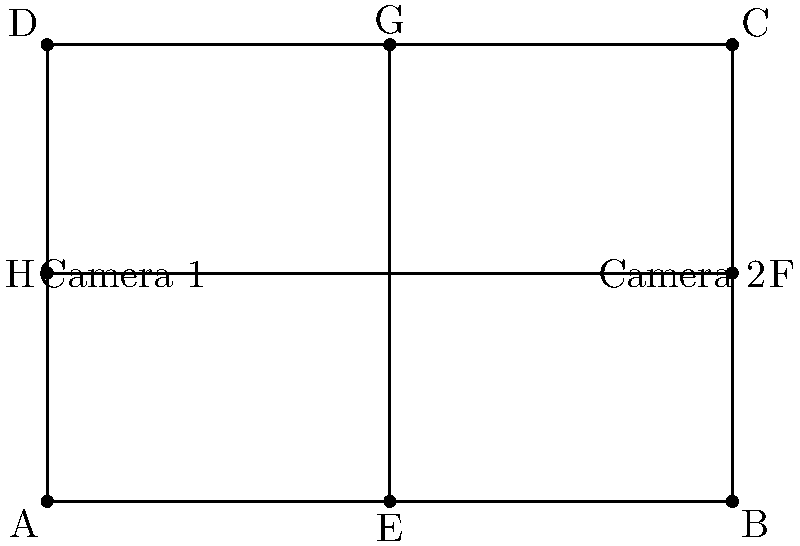A rectangular property has security cameras installed at points E and F as shown in the diagram. If these cameras are reflected across the diagonal AC to create a symmetrical layout, where will the new camera positions be located? To solve this problem, we need to understand the concept of reflection symmetry across a diagonal. Here's a step-by-step explanation:

1. Identify the line of symmetry: In this case, it's the diagonal AC of the rectangular property.

2. For Camera 1 at point E:
   a. Draw a perpendicular line from E to AC.
   b. Extend this line an equal distance on the other side of AC.
   c. The endpoint of this extended line is the reflection of E, which is point G.

3. For Camera 2 at point F:
   a. Draw a perpendicular line from F to AC.
   b. Extend this line an equal distance on the other side of AC.
   c. The endpoint of this extended line is the reflection of F, which is point H.

4. Verify that the distances are equal:
   $AE = AG$ and $CF = CH$

5. Check that the angles are preserved:
   $\angle EAC = \angle GAC$ and $\angle FCA = \angle HCA$

Therefore, the new camera positions after reflection across diagonal AC will be at points G and H.
Answer: Points G and H 